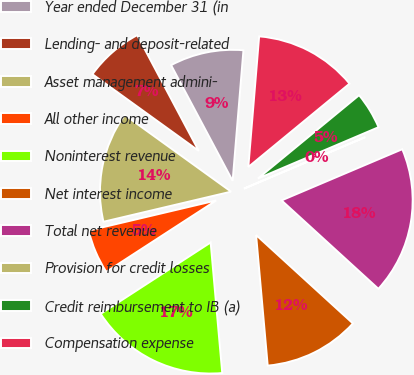Convert chart to OTSL. <chart><loc_0><loc_0><loc_500><loc_500><pie_chart><fcel>Year ended December 31 (in<fcel>Lending- and deposit-related<fcel>Asset management admini-<fcel>All other income<fcel>Noninterest revenue<fcel>Net interest income<fcel>Total net revenue<fcel>Provision for credit losses<fcel>Credit reimbursement to IB (a)<fcel>Compensation expense<nl><fcel>9.09%<fcel>7.28%<fcel>13.63%<fcel>5.47%<fcel>17.25%<fcel>11.81%<fcel>18.16%<fcel>0.02%<fcel>4.56%<fcel>12.72%<nl></chart> 